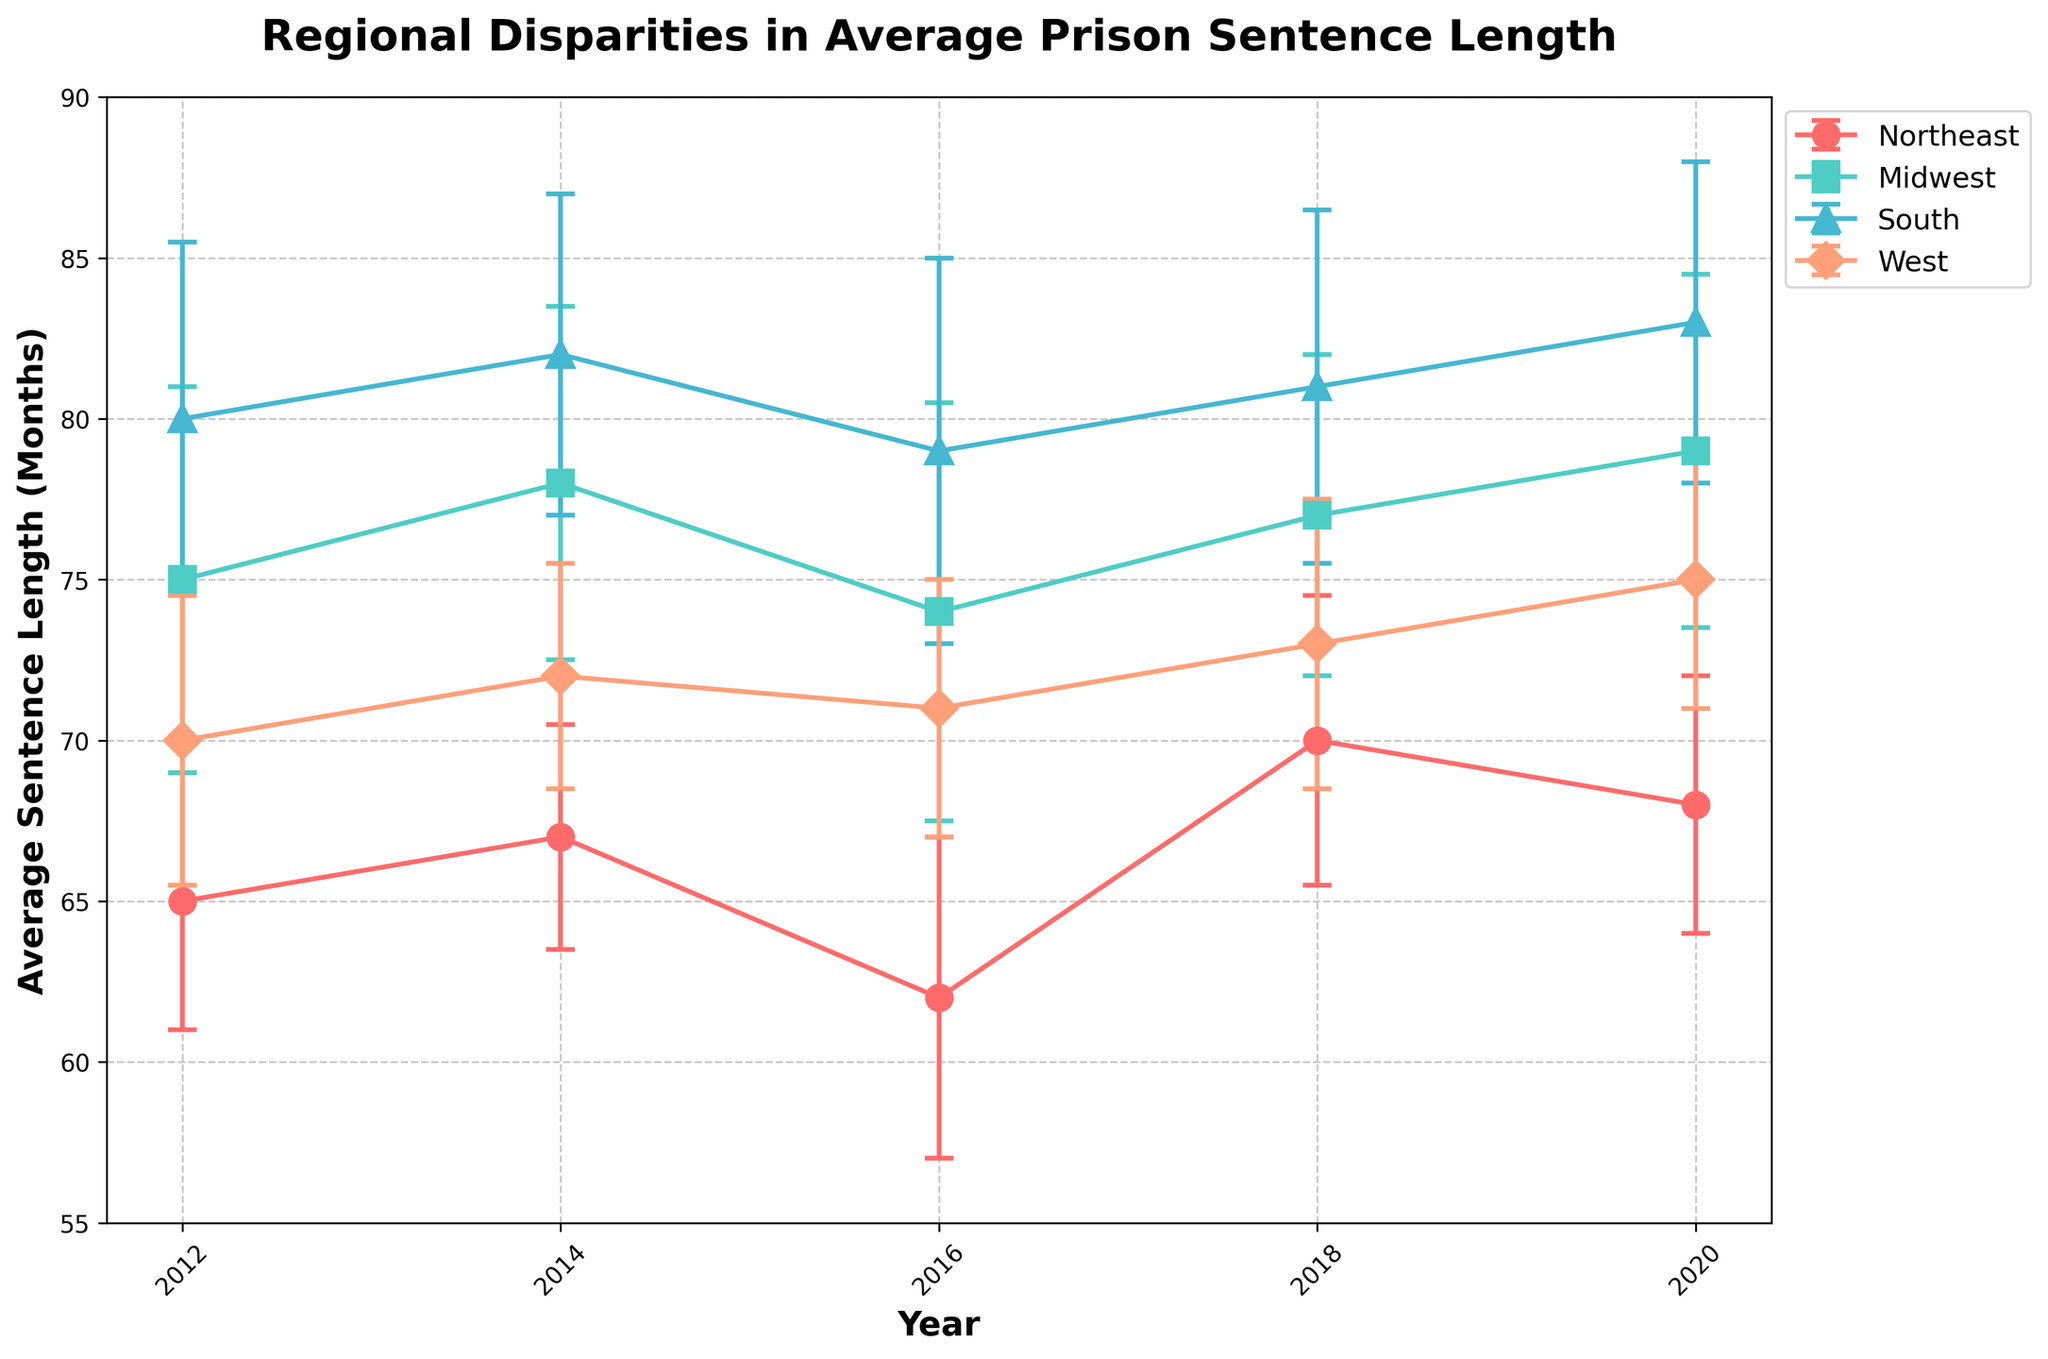What is the title of the plot? The title of the plot is written in bold at the top. It is "Regional Disparities in Average Prison Sentence Length".
Answer: Regional Disparities in Average Prison Sentence Length What years are represented on the x-axis? The x-axis shows the years from 2012 to 2020 in increments of two years.
Answer: 2012, 2014, 2016, 2018, 2020 Which region has the highest average sentence length in 2020? By comparing the average sentence lengths for 2020 among regions, the South shows the highest value.
Answer: South What is the range of the y-axis on the plot? The y-axis ranges from 55 to 90 as shown by the minimum and maximum y-ticks on the axis.
Answer: 55 to 90 Compare the sentence lengths in the Midwest and West in 2014. Which is greater? For 2014, the plot shows Midwest with an average sentence length of 78 months, while West has 72 months. Therefore, the Midwest is greater.
Answer: Midwest How does the average sentence length in the South in 2018 compare to 2012? Based on the data points, the South had an average sentence length of 80 months in 2012 and 81 months in 2018, so 2018 is slightly higher.
Answer: 2018 is slightly higher Which region shows the greatest variability in average sentence length over the decade? The Midwest has the largest variation in average sentence length, ranging from 74 months to 79 months with various standard errors.
Answer: Midwest What is the average sentence length trend in the Northeast from 2012 to 2020? Examining the plotted points from 2012 to 2020, the average sentence length in the Northeast starts at 65 months in 2012, fluctuates, and ends at 68 months in 2020, indicating a slight increase overall.
Answer: Slight increase What is the difference in average sentence length between the South and Northeast in 2020? In 2020, the South has an average sentence length of 83 months and the Northeast has 68 months, resulting in a difference of 15 months.
Answer: 15 months Which region has the smallest error bar for any of the years shown, and what year is it? The error bar sizes can be visually compared, and the smallest is for the Northeast in 2014 with a standard error of 3.5.
Answer: Northeast, 2014 